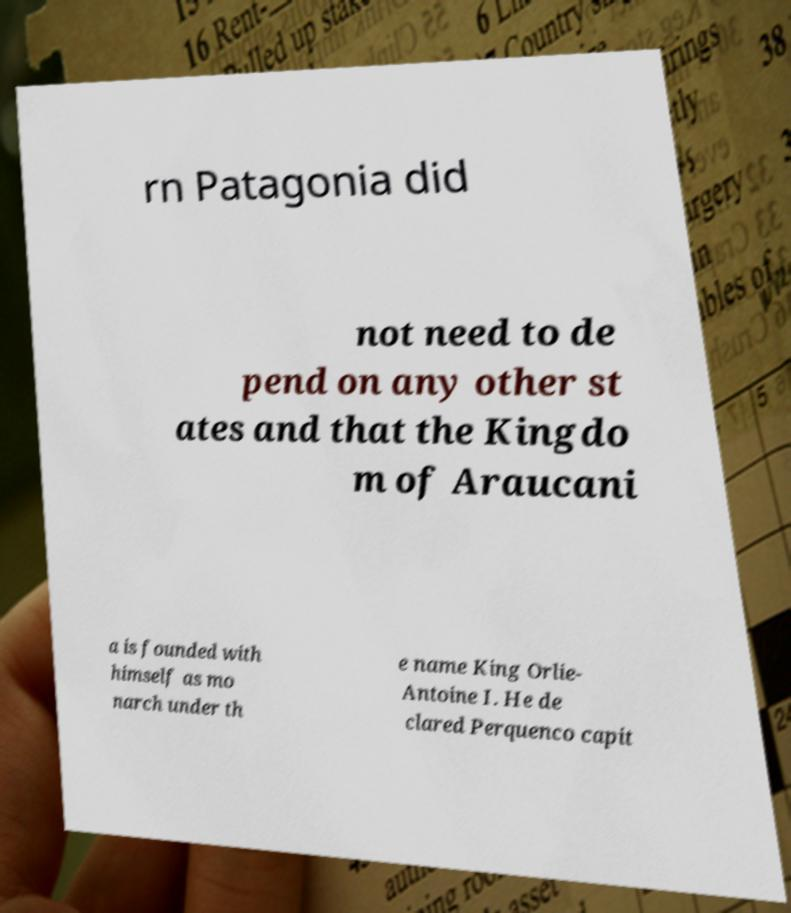Please read and relay the text visible in this image. What does it say? rn Patagonia did not need to de pend on any other st ates and that the Kingdo m of Araucani a is founded with himself as mo narch under th e name King Orlie- Antoine I. He de clared Perquenco capit 